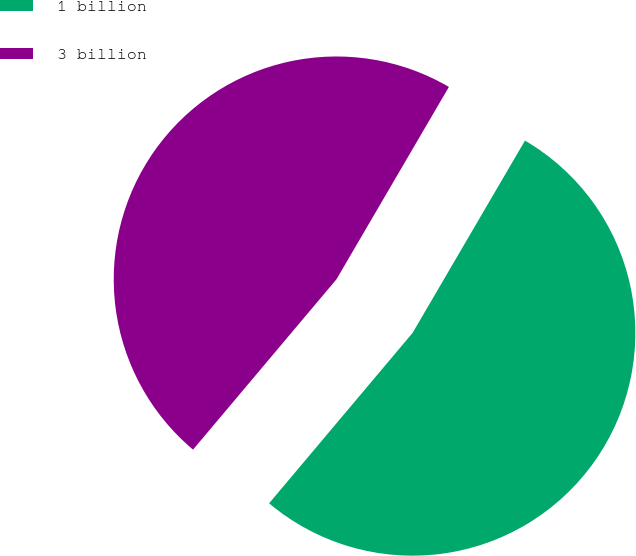<chart> <loc_0><loc_0><loc_500><loc_500><pie_chart><fcel>1 billion<fcel>3 billion<nl><fcel>52.72%<fcel>47.28%<nl></chart> 